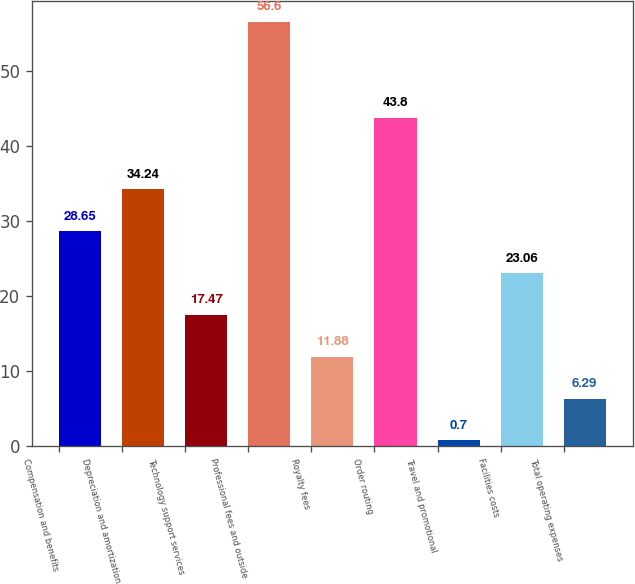<chart> <loc_0><loc_0><loc_500><loc_500><bar_chart><fcel>Compensation and benefits<fcel>Depreciation and amortization<fcel>Technology support services<fcel>Professional fees and outside<fcel>Royalty fees<fcel>Order routing<fcel>Travel and promotional<fcel>Facilities costs<fcel>Total operating expenses<nl><fcel>28.65<fcel>34.24<fcel>17.47<fcel>56.6<fcel>11.88<fcel>43.8<fcel>0.7<fcel>23.06<fcel>6.29<nl></chart> 